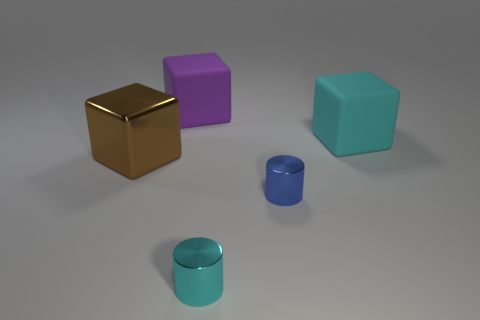There is a large object that is right of the cyan shiny object; what shape is it? cube 